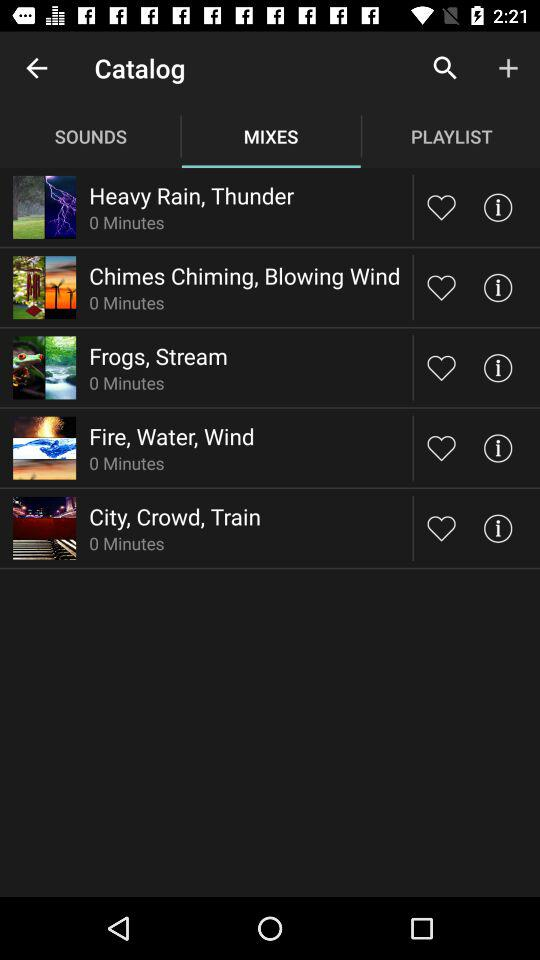What is the selected tab? The selected tab is "MIXES". 